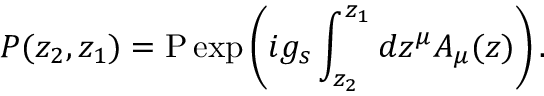Convert formula to latex. <formula><loc_0><loc_0><loc_500><loc_500>P ( z _ { 2 } , z _ { 1 } ) = P \exp \left ( i g _ { s } \int _ { z _ { 2 } } ^ { z _ { 1 } } d z ^ { \mu } A _ { \mu } ( z ) \right ) .</formula> 